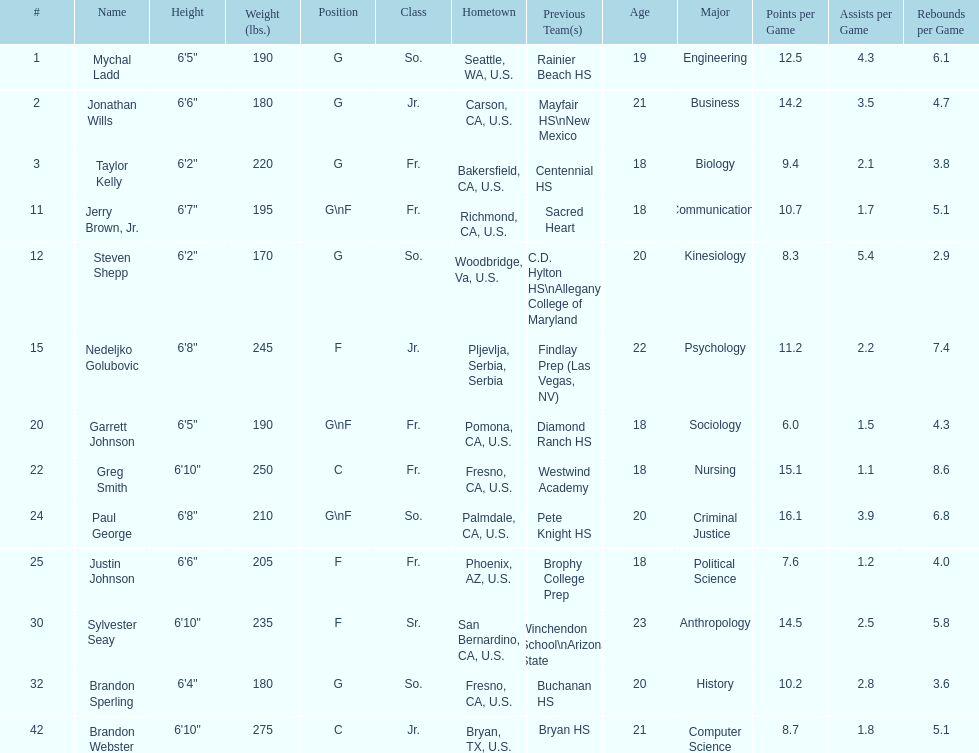Who weighs the most on the team? Brandon Webster. Can you parse all the data within this table? {'header': ['#', 'Name', 'Height', 'Weight (lbs.)', 'Position', 'Class', 'Hometown', 'Previous Team(s)', 'Age', 'Major', 'Points per Game', 'Assists per Game', 'Rebounds per Game'], 'rows': [['1', 'Mychal Ladd', '6\'5"', '190', 'G', 'So.', 'Seattle, WA, U.S.', 'Rainier Beach HS', '19', 'Engineering', '12.5', '4.3', '6.1'], ['2', 'Jonathan Wills', '6\'6"', '180', 'G', 'Jr.', 'Carson, CA, U.S.', 'Mayfair HS\\nNew Mexico', '21', 'Business', '14.2', '3.5', '4.7'], ['3', 'Taylor Kelly', '6\'2"', '220', 'G', 'Fr.', 'Bakersfield, CA, U.S.', 'Centennial HS', '18', 'Biology', '9.4', '2.1', '3.8'], ['11', 'Jerry Brown, Jr.', '6\'7"', '195', 'G\\nF', 'Fr.', 'Richmond, CA, U.S.', 'Sacred Heart', '18', 'Communications', '10.7', '1.7', '5.1'], ['12', 'Steven Shepp', '6\'2"', '170', 'G', 'So.', 'Woodbridge, Va, U.S.', 'C.D. Hylton HS\\nAllegany College of Maryland', '20', 'Kinesiology', '8.3', '5.4', '2.9'], ['15', 'Nedeljko Golubovic', '6\'8"', '245', 'F', 'Jr.', 'Pljevlja, Serbia, Serbia', 'Findlay Prep (Las Vegas, NV)', '22', 'Psychology', '11.2', '2.2', '7.4'], ['20', 'Garrett Johnson', '6\'5"', '190', 'G\\nF', 'Fr.', 'Pomona, CA, U.S.', 'Diamond Ranch HS', '18', 'Sociology', '6.0', '1.5', '4.3'], ['22', 'Greg Smith', '6\'10"', '250', 'C', 'Fr.', 'Fresno, CA, U.S.', 'Westwind Academy', '18', 'Nursing', '15.1', '1.1', '8.6'], ['24', 'Paul George', '6\'8"', '210', 'G\\nF', 'So.', 'Palmdale, CA, U.S.', 'Pete Knight HS', '20', 'Criminal Justice', '16.1', '3.9', '6.8'], ['25', 'Justin Johnson', '6\'6"', '205', 'F', 'Fr.', 'Phoenix, AZ, U.S.', 'Brophy College Prep', '18', 'Political Science', '7.6', '1.2', '4.0'], ['30', 'Sylvester Seay', '6\'10"', '235', 'F', 'Sr.', 'San Bernardino, CA, U.S.', 'Winchendon School\\nArizona State', '23', 'Anthropology', '14.5', '2.5', '5.8'], ['32', 'Brandon Sperling', '6\'4"', '180', 'G', 'So.', 'Fresno, CA, U.S.', 'Buchanan HS', '20', 'History', '10.2', '2.8', '3.6'], ['42', 'Brandon Webster', '6\'10"', '275', 'C', 'Jr.', 'Bryan, TX, U.S.', 'Bryan HS', '21', 'Computer Science', '8.7', '1.8', '5.1']]} 